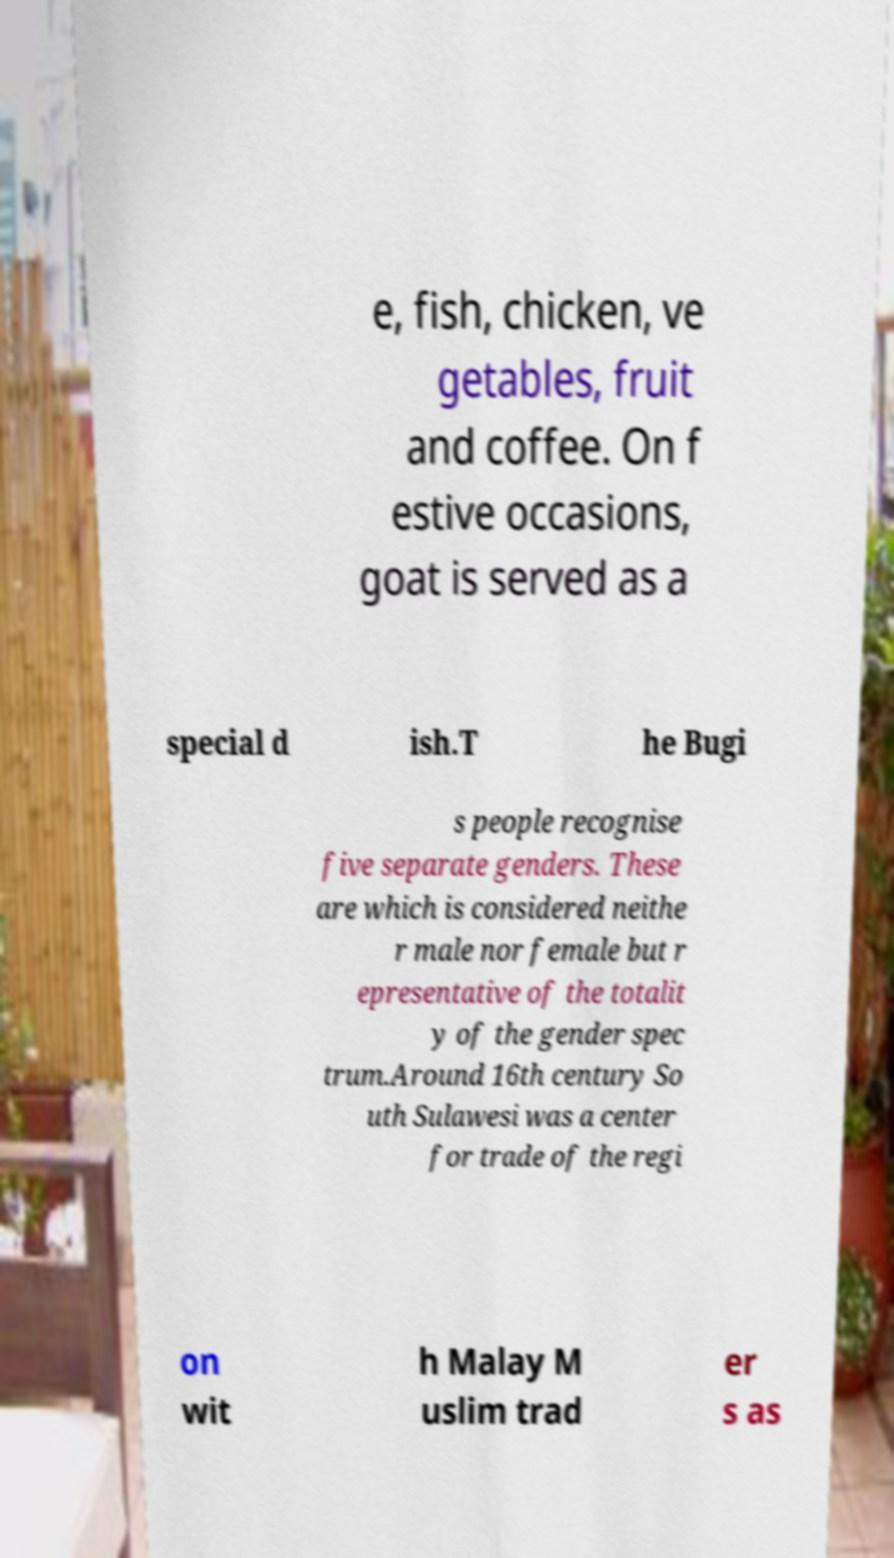Can you read and provide the text displayed in the image?This photo seems to have some interesting text. Can you extract and type it out for me? e, fish, chicken, ve getables, fruit and coffee. On f estive occasions, goat is served as a special d ish.T he Bugi s people recognise five separate genders. These are which is considered neithe r male nor female but r epresentative of the totalit y of the gender spec trum.Around 16th century So uth Sulawesi was a center for trade of the regi on wit h Malay M uslim trad er s as 